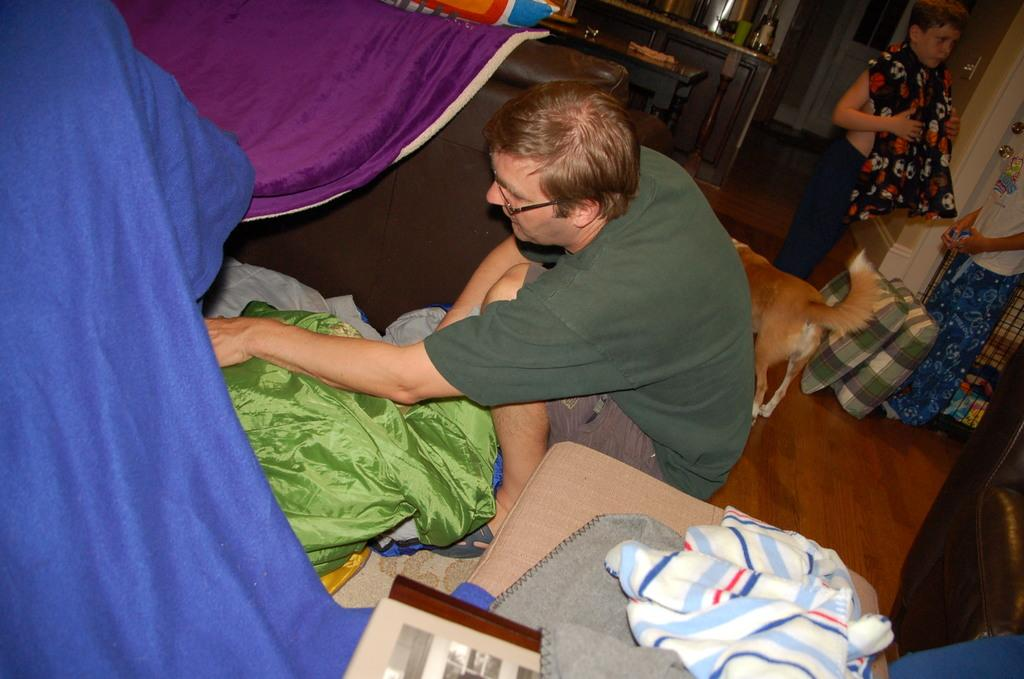What is: What is on the floor in the image? There is a dog on the floor in the image. How many people are in the image? There are three people in the image. What can be seen on the people in the image? Clothes are present in the image. What type of furniture is visible in the background of the image? Pillows and a table are visible in the background of the image. What is the background of the image composed of? There is a wall and some objects in the background of the image. Can you tell me how many veins are visible on the dog in the image? There is no mention of veins in the image, and it is not possible to determine the visibility of veins on the dog from the provided facts. What type of development is taking place in the image? There is no indication of any development or construction in the image; it primarily features a dog, people, and furniture. 